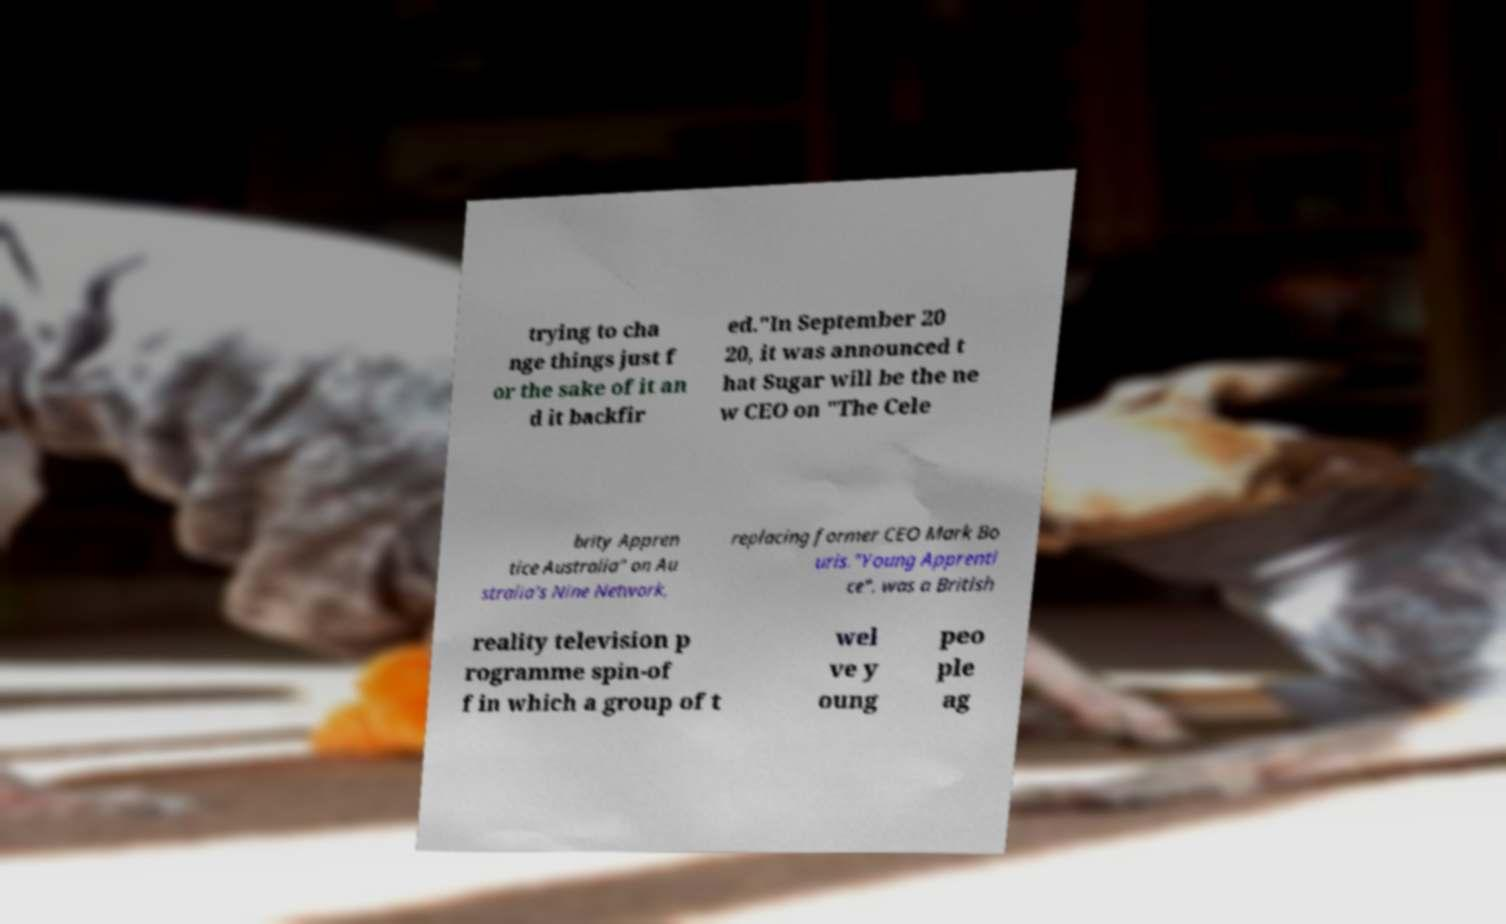For documentation purposes, I need the text within this image transcribed. Could you provide that? trying to cha nge things just f or the sake of it an d it backfir ed."In September 20 20, it was announced t hat Sugar will be the ne w CEO on "The Cele brity Appren tice Australia" on Au stralia's Nine Network, replacing former CEO Mark Bo uris."Young Apprenti ce". was a British reality television p rogramme spin-of f in which a group of t wel ve y oung peo ple ag 